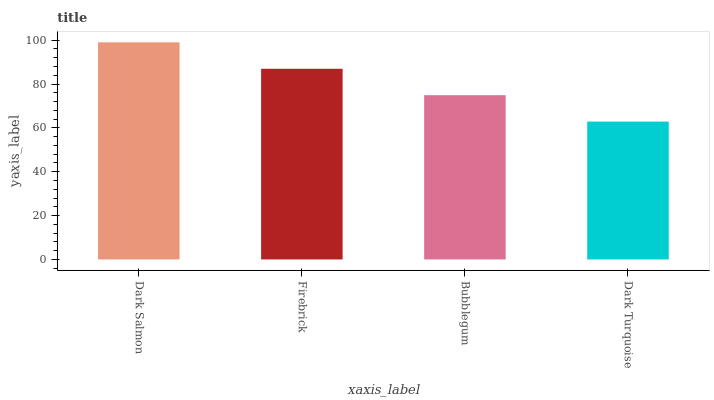Is Dark Turquoise the minimum?
Answer yes or no. Yes. Is Dark Salmon the maximum?
Answer yes or no. Yes. Is Firebrick the minimum?
Answer yes or no. No. Is Firebrick the maximum?
Answer yes or no. No. Is Dark Salmon greater than Firebrick?
Answer yes or no. Yes. Is Firebrick less than Dark Salmon?
Answer yes or no. Yes. Is Firebrick greater than Dark Salmon?
Answer yes or no. No. Is Dark Salmon less than Firebrick?
Answer yes or no. No. Is Firebrick the high median?
Answer yes or no. Yes. Is Bubblegum the low median?
Answer yes or no. Yes. Is Bubblegum the high median?
Answer yes or no. No. Is Dark Turquoise the low median?
Answer yes or no. No. 